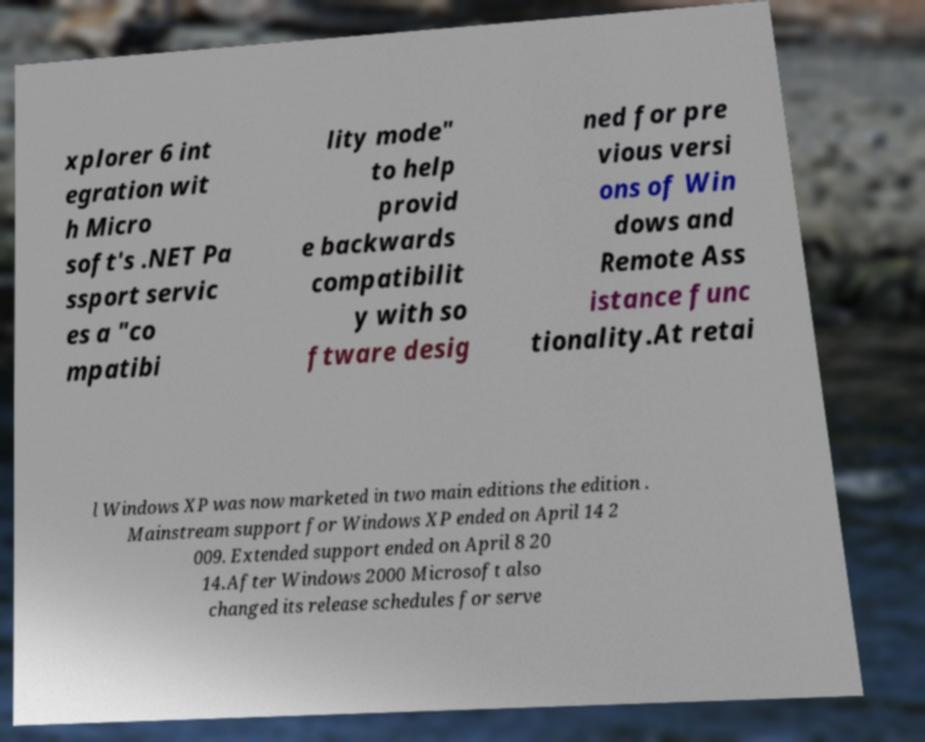Please identify and transcribe the text found in this image. xplorer 6 int egration wit h Micro soft's .NET Pa ssport servic es a "co mpatibi lity mode" to help provid e backwards compatibilit y with so ftware desig ned for pre vious versi ons of Win dows and Remote Ass istance func tionality.At retai l Windows XP was now marketed in two main editions the edition . Mainstream support for Windows XP ended on April 14 2 009. Extended support ended on April 8 20 14.After Windows 2000 Microsoft also changed its release schedules for serve 